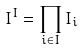Convert formula to latex. <formula><loc_0><loc_0><loc_500><loc_500>I ^ { I } = \prod _ { i \in I } I _ { i }</formula> 